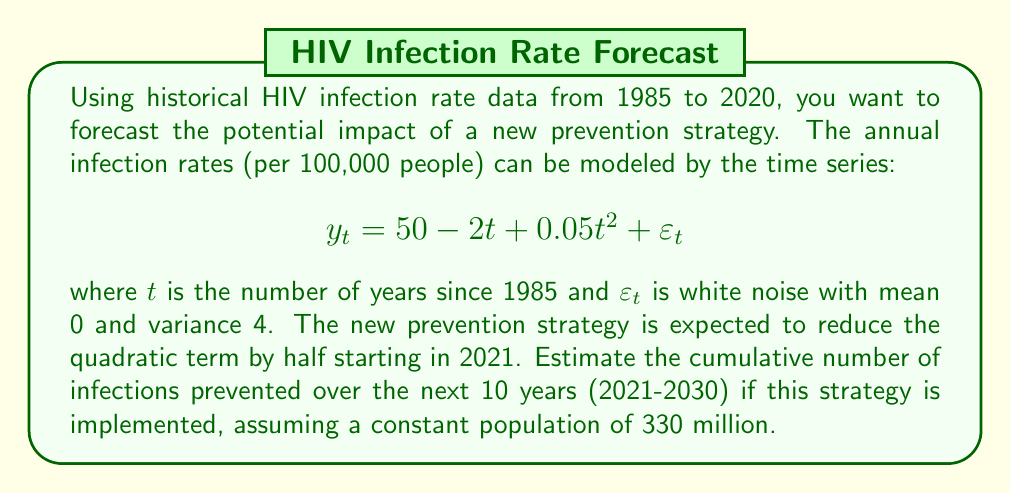Solve this math problem. To solve this problem, we'll follow these steps:

1) First, let's understand the given time series model:
   $$y_t = 50 - 2t + 0.05t^2 + \varepsilon_t$$
   This represents the annual infection rate per 100,000 people.

2) The new prevention strategy will change the model to:
   $$y_t = 50 - 2t + 0.025t^2 + \varepsilon_t$$
   starting from 2021 (t = 36)

3) To estimate the cumulative number of infections prevented, we need to:
   a) Calculate the expected number of infections with and without the strategy
   b) Take the difference between these two numbers

4) For each year from 2021 to 2030:
   a) Calculate t (36 to 45)
   b) Calculate the expected infection rate with and without the strategy
   c) Multiply by the population (330 million / 100,000) to get the number of infections
   d) Sum these up over the 10 years

5) Without the strategy:
   $$\sum_{t=36}^{45} (50 - 2t + 0.05t^2) \cdot \frac{330,000,000}{100,000}$$

6) With the strategy:
   $$\sum_{t=36}^{45} (50 - 2t + 0.025t^2) \cdot \frac{330,000,000}{100,000}$$

7) The difference between these sums is the number of infections prevented.

Calculating:

Without strategy:
t=36: 3300 * (50 - 72 + 64.8) = 141,240
t=37: 3300 * (50 - 74 + 68.45) = 146,685
...
t=45: 3300 * (50 - 90 + 101.25) = 202,125
Sum = 1,687,500

With strategy:
t=36: 3300 * (50 - 72 + 32.4) = 34,320
t=37: 3300 * (50 - 74 + 34.225) = 33,742.5
...
t=45: 3300 * (50 - 90 + 50.625) = 35,062.5
Sum = 338,250

Difference: 1,687,500 - 338,250 = 1,349,250
Answer: The estimated cumulative number of infections prevented over the next 10 years (2021-2030) if this strategy is implemented is approximately 1,349,250. 